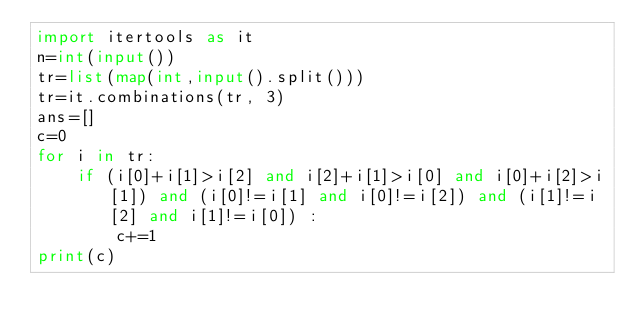<code> <loc_0><loc_0><loc_500><loc_500><_Python_>import itertools as it
n=int(input())
tr=list(map(int,input().split()))
tr=it.combinations(tr, 3)
ans=[]
c=0
for i in tr:
    if (i[0]+i[1]>i[2] and i[2]+i[1]>i[0] and i[0]+i[2]>i[1]) and (i[0]!=i[1] and i[0]!=i[2]) and (i[1]!=i[2] and i[1]!=i[0]) :
        c+=1
print(c)</code> 